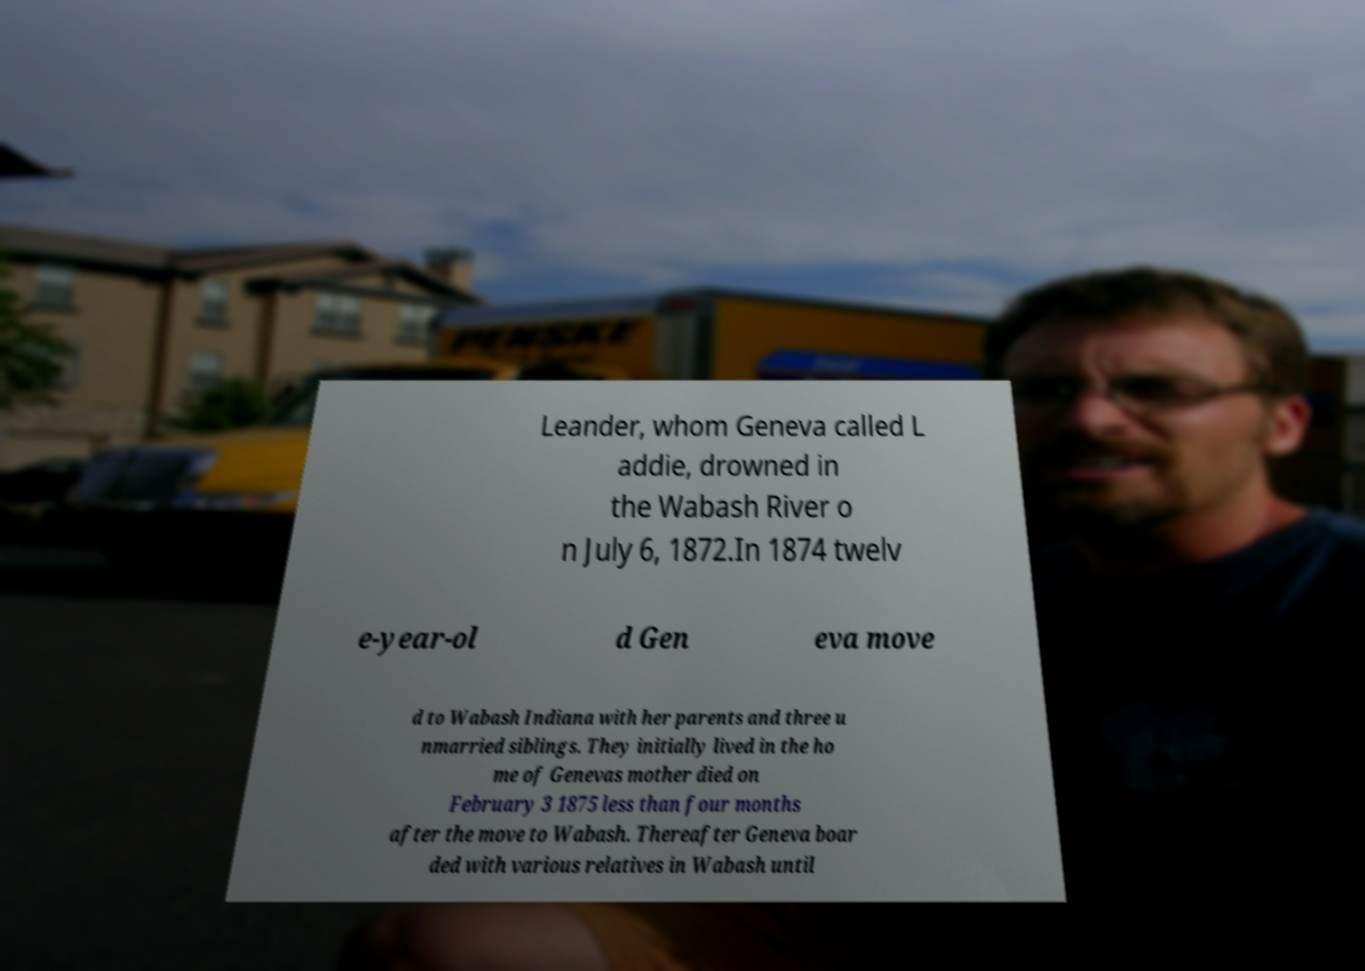Can you accurately transcribe the text from the provided image for me? Leander, whom Geneva called L addie, drowned in the Wabash River o n July 6, 1872.In 1874 twelv e-year-ol d Gen eva move d to Wabash Indiana with her parents and three u nmarried siblings. They initially lived in the ho me of Genevas mother died on February 3 1875 less than four months after the move to Wabash. Thereafter Geneva boar ded with various relatives in Wabash until 